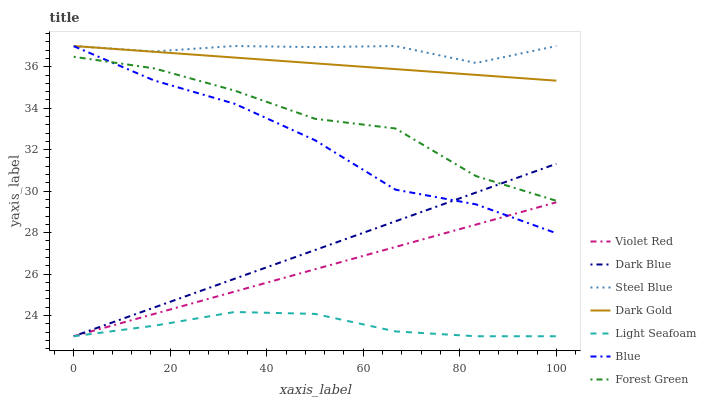Does Light Seafoam have the minimum area under the curve?
Answer yes or no. Yes. Does Steel Blue have the maximum area under the curve?
Answer yes or no. Yes. Does Violet Red have the minimum area under the curve?
Answer yes or no. No. Does Violet Red have the maximum area under the curve?
Answer yes or no. No. Is Dark Blue the smoothest?
Answer yes or no. Yes. Is Forest Green the roughest?
Answer yes or no. Yes. Is Violet Red the smoothest?
Answer yes or no. No. Is Violet Red the roughest?
Answer yes or no. No. Does Violet Red have the lowest value?
Answer yes or no. Yes. Does Dark Gold have the lowest value?
Answer yes or no. No. Does Steel Blue have the highest value?
Answer yes or no. Yes. Does Violet Red have the highest value?
Answer yes or no. No. Is Violet Red less than Dark Gold?
Answer yes or no. Yes. Is Blue greater than Light Seafoam?
Answer yes or no. Yes. Does Blue intersect Forest Green?
Answer yes or no. Yes. Is Blue less than Forest Green?
Answer yes or no. No. Is Blue greater than Forest Green?
Answer yes or no. No. Does Violet Red intersect Dark Gold?
Answer yes or no. No. 